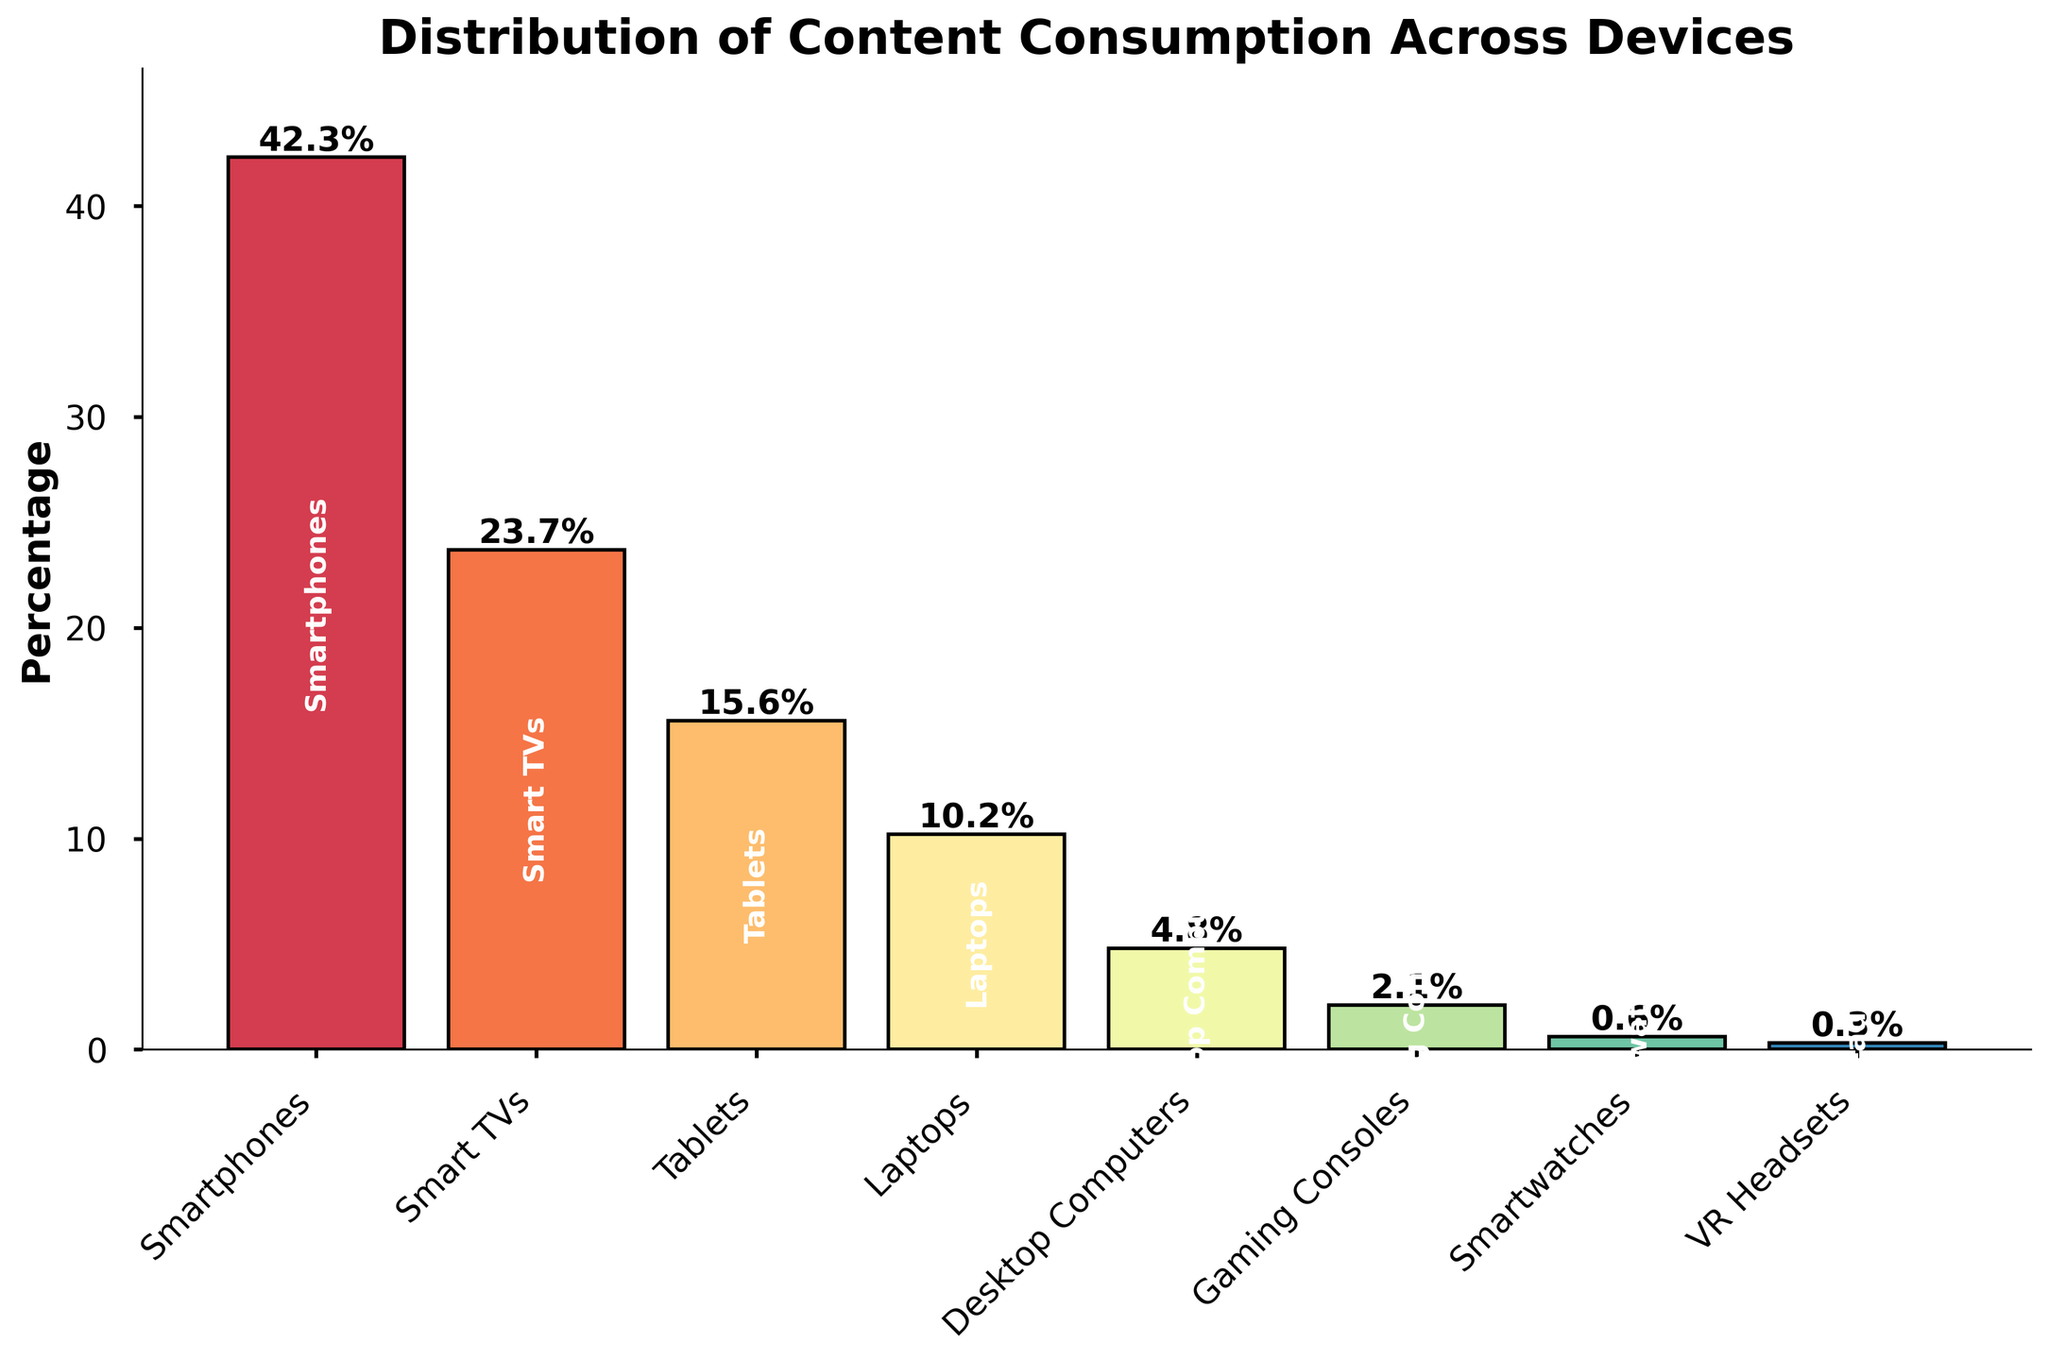What device has the highest percentage of content consumption? By looking at the height of the bars, we notice that the bar for Smartphones is the tallest, indicating it has the highest percentage.
Answer: Smartphones Which devices combined account for over 50% of content consumption? Adding the percentages for Smartphones (42.3%) and Smart TVs (23.7%) results in 66%, which is over 50%.
Answer: Smartphones and Smart TVs What's the percentage difference between Smart TVs and Tablets? The percentage of content consumption for Smart TVs is 23.7% and for Tablets is 15.6%. The difference is 23.7% - 15.6% = 8.1%.
Answer: 8.1% How much more content is consumed on Smartphones compared to Laptops? The percentage for Smartphones is 42.3% and for Laptops is 10.2%. The difference is 42.3% - 10.2% = 32.1%.
Answer: 32.1% Which devices have a content consumption percentage below 5%? The bars for Desktop Computers (4.8%), Gaming Consoles (2.1%), Smartwatches (0.6%), and VR Headsets (0.3%) all fall below the 5% mark.
Answer: Desktop Computers, Gaming Consoles, Smartwatches, and VR Headsets What is the total percentage of content consumption on all devices combined? Adding up the percentages for all devices: 42.3% + 23.7% + 15.6% + 10.2% + 4.8% + 2.1% + 0.6% + 0.3% = 99.6%.
Answer: 99.6% Are Tablets used more for content consumption than Laptops? Comparing the heights of the bars for Tablets (15.6%) and Laptops (10.2%), we see that the Tablet bar is taller.
Answer: Yes What is the approximate average percentage of content consumption across all devices? Adding up the percentages for all devices: 42.3 + 23.7 + 15.6 + 10.2 + 4.8 + 2.1 + 0.6 + 0.3 = 99.6, then dividing by 8 (number of devices) gives an average: 99.6 / 8 ≈ 12.45%.
Answer: 12.45% Which device has the smallest share of content consumption, and what is it? The bar for VR Headsets is the shortest, indicating the smallest percentage of 0.3%.
Answer: VR Headsets, 0.3% How does the content consumption on Gaming Consoles compare to that on Smart TVs? Comparing the height of the bars, Smart TVs have a significantly higher percentage (23.7%) than Gaming Consoles (2.1%).
Answer: Smart TVs have higher consumption 